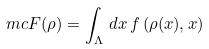Convert formula to latex. <formula><loc_0><loc_0><loc_500><loc_500>\ m c F ( \rho ) = \int _ { \Lambda } \, d x \, f \left ( \rho ( x ) , x \right )</formula> 